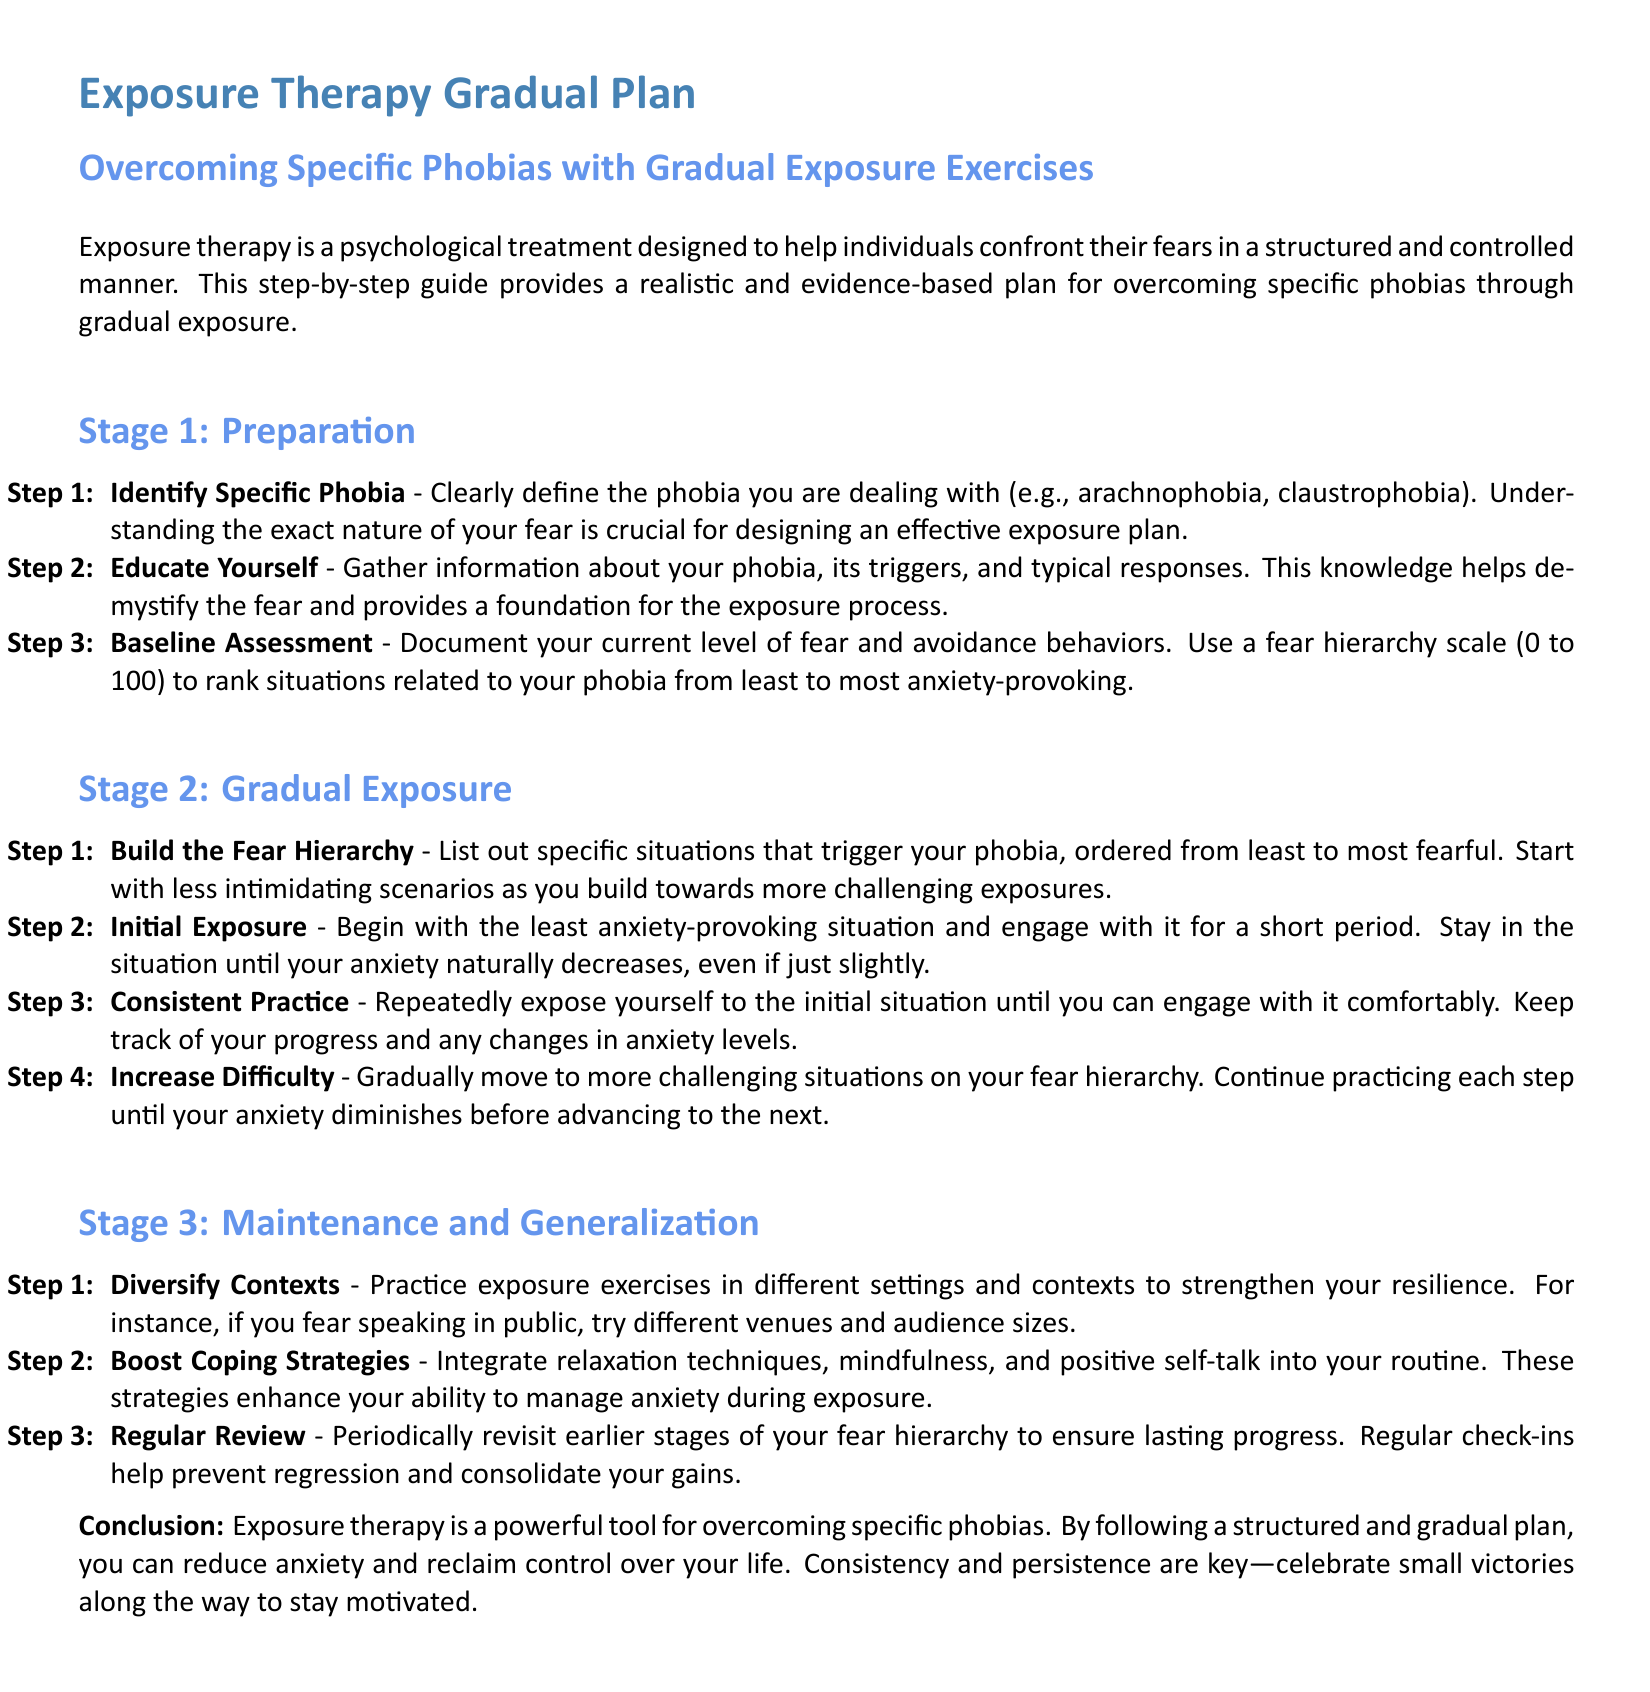what is the title of the document? The title is provided in the document, which highlights the main topic of the guide.
Answer: Exposure Therapy Gradual Plan how many stages are in the exposure therapy plan? The number of stages is explicitly stated in the document as part of the structured plan.
Answer: Three what is the focus of Stage 1? This stage is outlined to provide a foundational understanding before exposure begins.
Answer: Preparation what is the first step in Stage 2? This step is the initial action outlined for engaging with the fear hierarchy.
Answer: Build the Fear Hierarchy what should you do during the Regular Review step? This step reflects on the importance of revisiting previous stages for sustained progress.
Answer: Periodically revisit earlier stages which stage involves diversifying contexts? The document specifies which stage focuses on broadening the settings for exposure exercises.
Answer: Stage 3 what is suggested to boost coping strategies? This detail addresses how to enhance your skills in managing anxiety through techniques.
Answer: Integrate relaxation techniques what type of therapy is discussed in the document? The therapy type is central to the content and is aimed at phobia treatment.
Answer: Exposure therapy how should one document their current level of fear? The method outlined in the document indicates a clear approach to measuring anxiety.
Answer: Use a fear hierarchy scale 